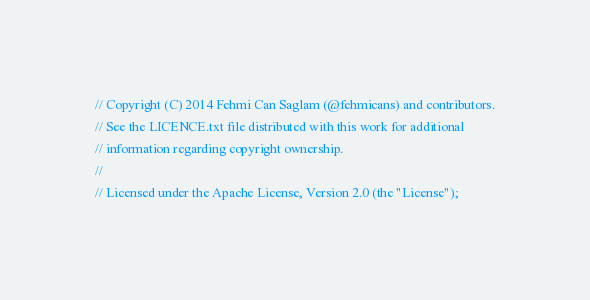Convert code to text. <code><loc_0><loc_0><loc_500><loc_500><_Scala_>// Copyright (C) 2014 Fehmi Can Saglam (@fehmicans) and contributors.
// See the LICENCE.txt file distributed with this work for additional
// information regarding copyright ownership.
//
// Licensed under the Apache License, Version 2.0 (the "License");</code> 